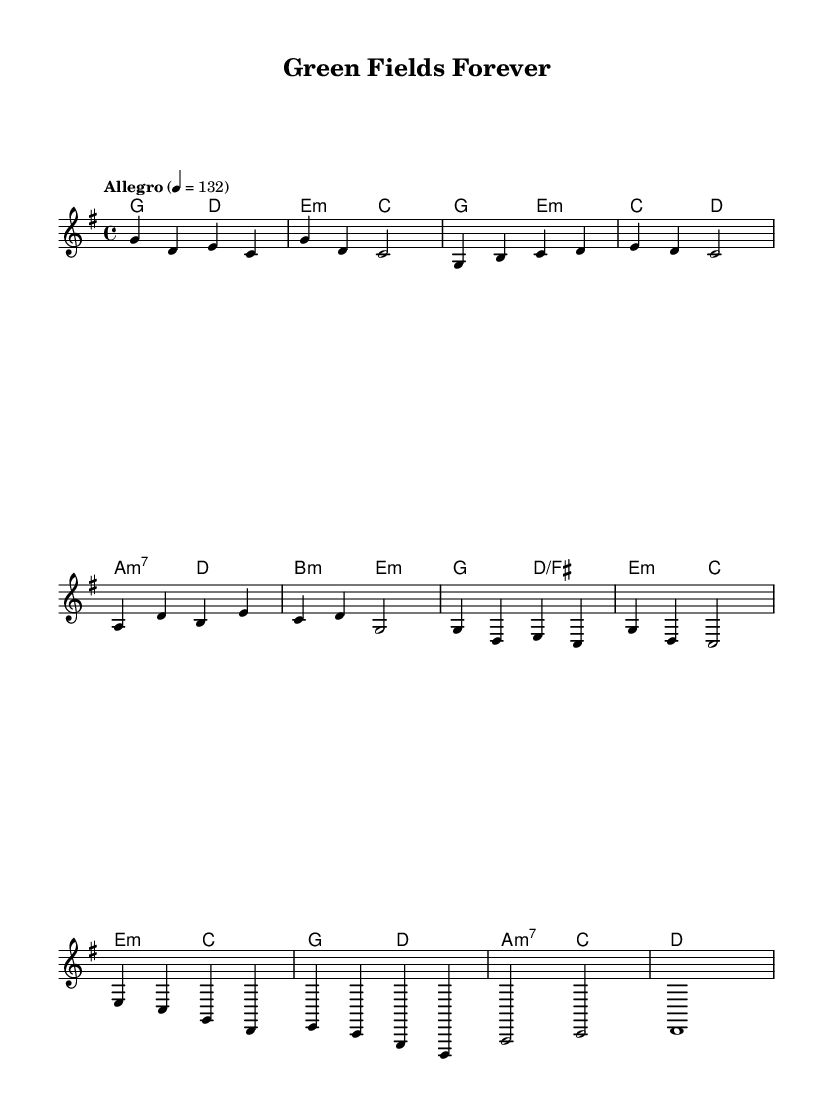What is the key signature of this music? The key signature is G major, which has one sharp (F#). This can be identified by looking at the key signature on the left-hand side of the staff at the beginning of the score.
Answer: G major What is the time signature of this piece? The time signature is 4/4, indicated by the numbers placed at the beginning of the score. This means there are four beats in each measure and the quarter note gets one beat.
Answer: 4/4 What is the tempo marking for this song? The tempo marking is "Allegro," and it specifies a speed of 132 beats per minute (indicated as 4 = 132) at the beginning of the score. This relates to the lively and fast-paced nature typical of K-Pop songs.
Answer: Allegro How many measures are in the chorus section? The chorus section consists of two measures, as identified by the repeated musical phrases in the score that present the core theme of the piece. Each measure is full of musical notes and corresponds to the high-energy parts found in K-Pop music.
Answer: 2 What chord follows the pre-chorus in the chord progression? The chord that follows the pre-chorus is G major (g). This can be determined by looking at the chord names along the staff and noting the sequence that leads from the pre-chorus to the chorus.
Answer: G major What is the melodic shape of the bridge section compared to the verse? The melodic shape of the bridge is upward and downward, exhibiting more variation compared to the verse, which is more repetitive and structured. This can be noticed in the direction of the notes in the bridge section, which display greater range and contrast typical of K-Pop dynamics.
Answer: More variation 